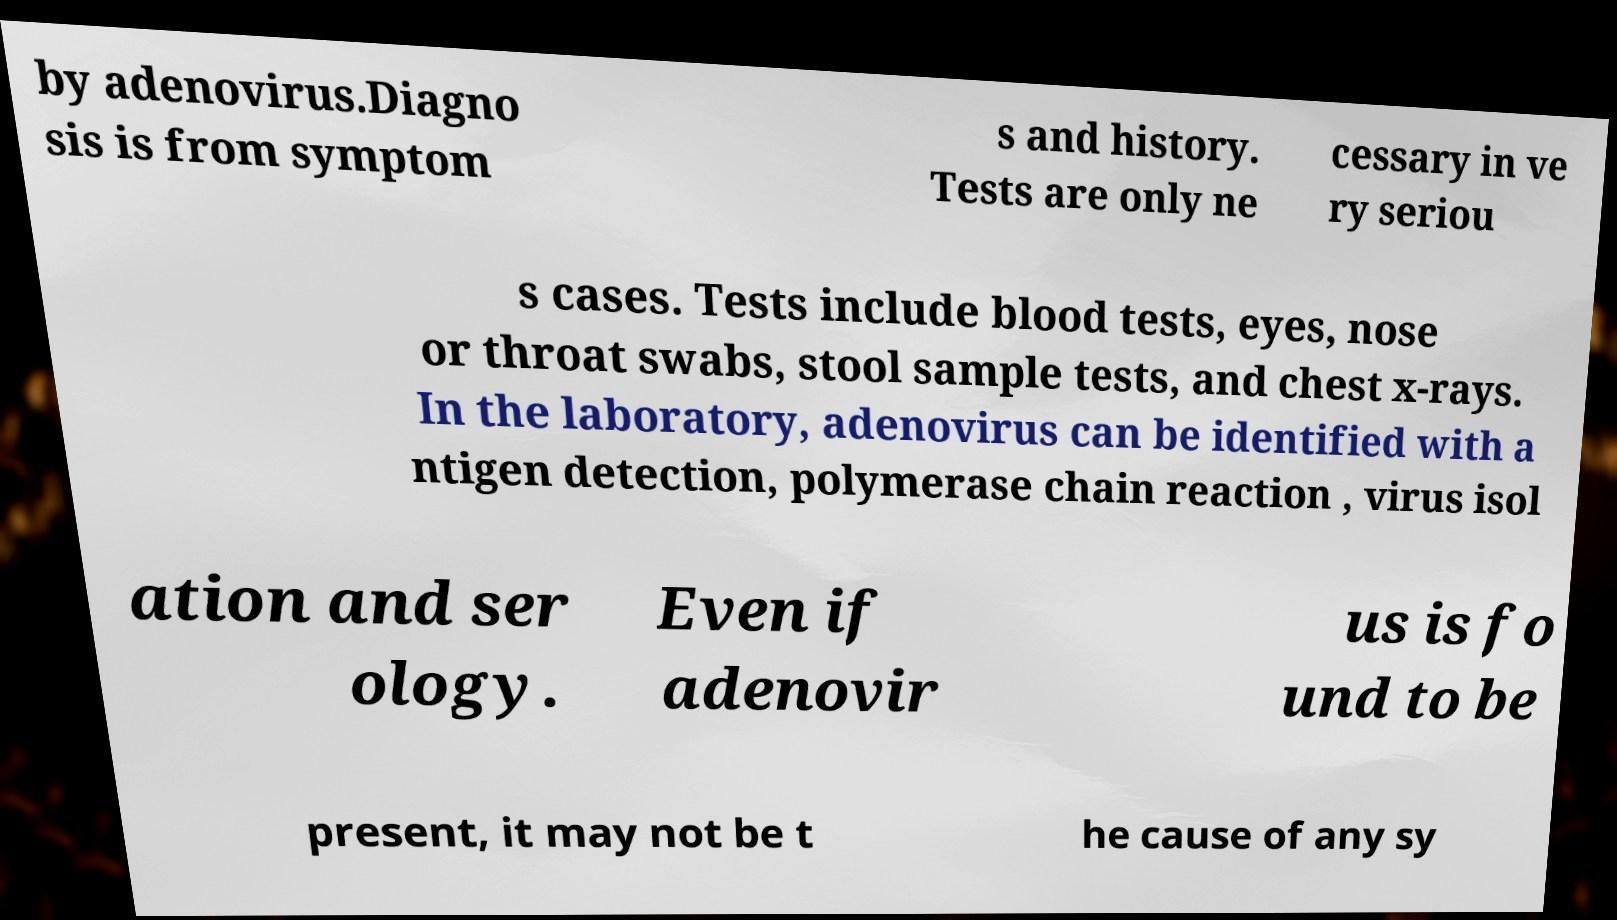Can you accurately transcribe the text from the provided image for me? by adenovirus.Diagno sis is from symptom s and history. Tests are only ne cessary in ve ry seriou s cases. Tests include blood tests, eyes, nose or throat swabs, stool sample tests, and chest x-rays. In the laboratory, adenovirus can be identified with a ntigen detection, polymerase chain reaction , virus isol ation and ser ology. Even if adenovir us is fo und to be present, it may not be t he cause of any sy 